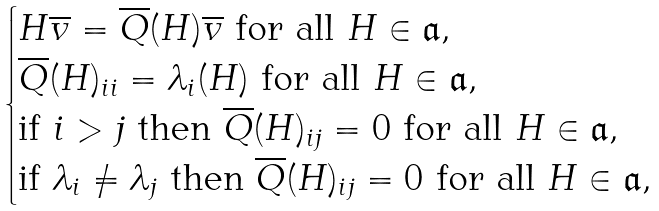Convert formula to latex. <formula><loc_0><loc_0><loc_500><loc_500>\begin{cases} \text {$H\overline{v} = \overline{Q}(H)\overline{v}$ for all $H\in \mathfrak{a}$} , \\ \text {$\overline{Q}(H)_{ii} = \lambda_{i}(H)$ for all $H\in \mathfrak{a}$} , \\ \text {if $i > j$ then $\overline{Q}(H)_{ij} = 0$ for all $H\in \mathfrak{a}$} , \\ \text {if $\lambda_{i} \ne \lambda_{j}$ then $\overline{Q}(H)_{ij} = 0$ for all $H\in \mathfrak{a}$} , \end{cases}</formula> 